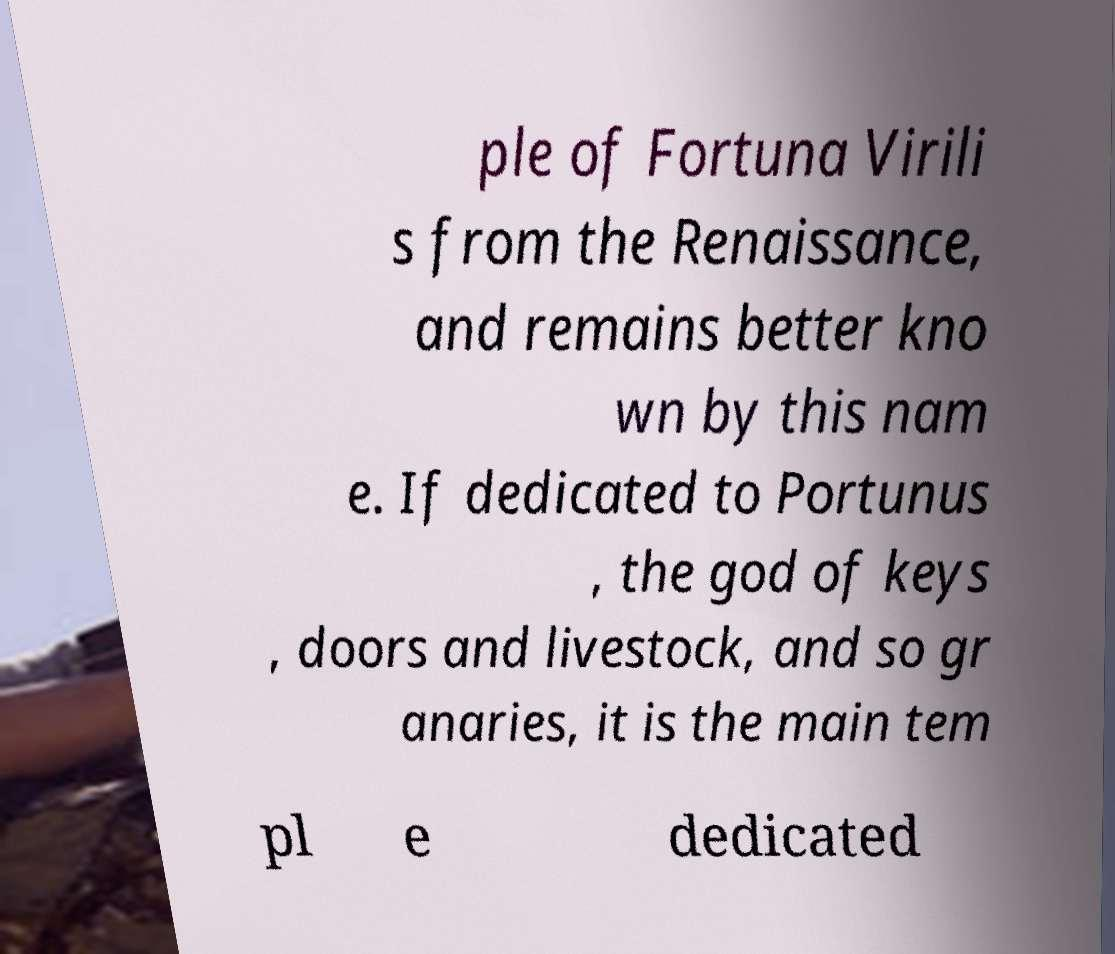Could you extract and type out the text from this image? ple of Fortuna Virili s from the Renaissance, and remains better kno wn by this nam e. If dedicated to Portunus , the god of keys , doors and livestock, and so gr anaries, it is the main tem pl e dedicated 